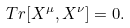<formula> <loc_0><loc_0><loc_500><loc_500>T r [ X ^ { \mu } , X ^ { \nu } ] = 0 .</formula> 